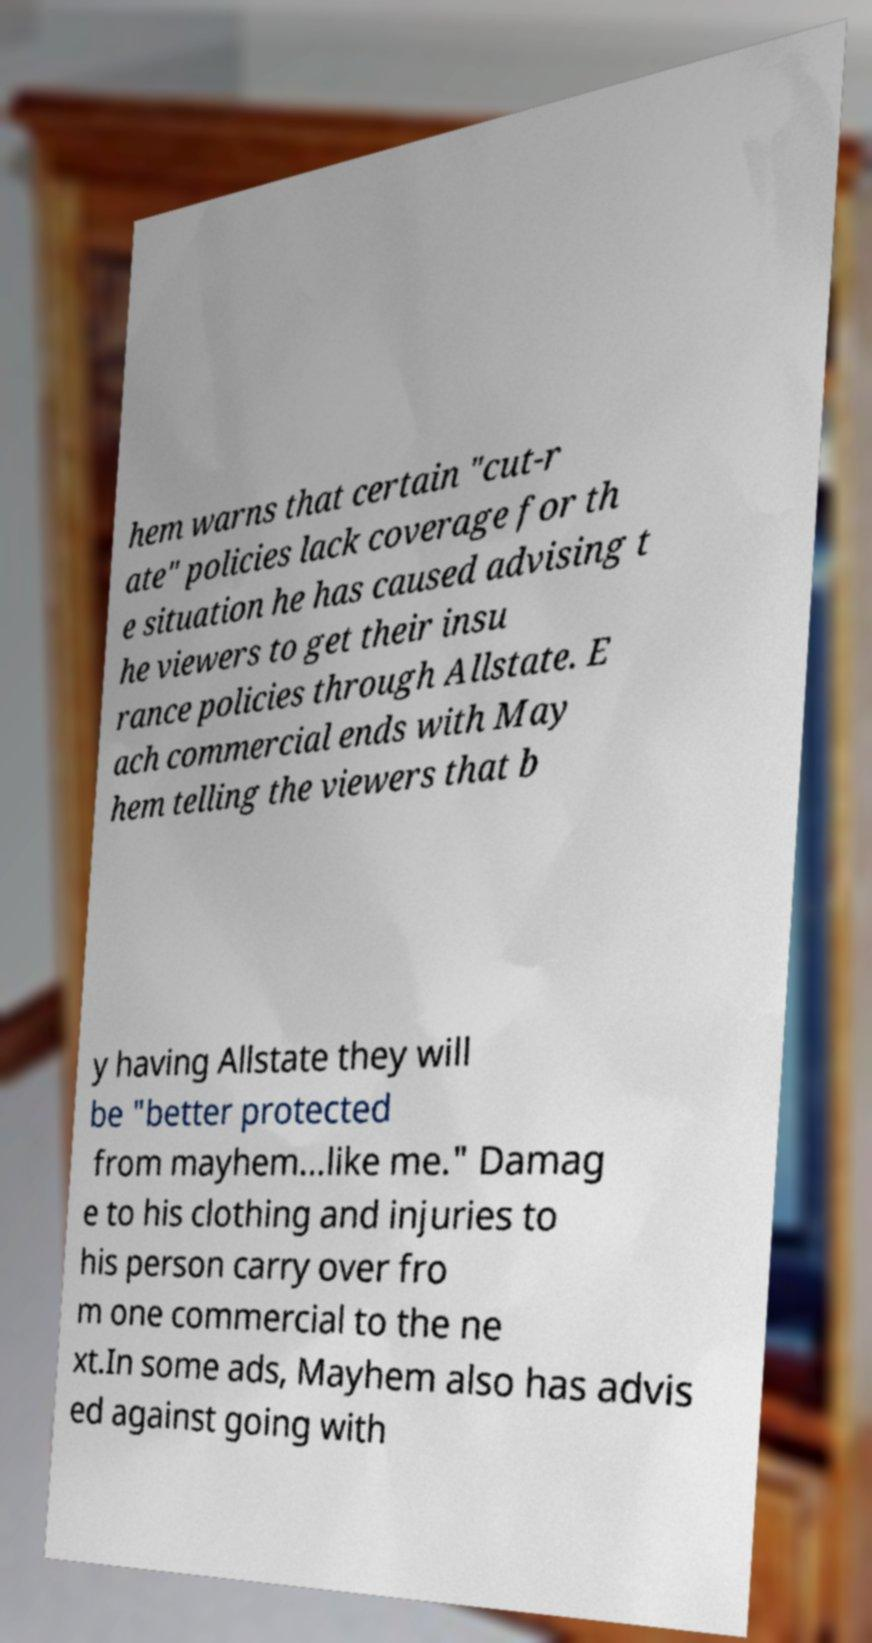I need the written content from this picture converted into text. Can you do that? hem warns that certain "cut-r ate" policies lack coverage for th e situation he has caused advising t he viewers to get their insu rance policies through Allstate. E ach commercial ends with May hem telling the viewers that b y having Allstate they will be "better protected from mayhem...like me." Damag e to his clothing and injuries to his person carry over fro m one commercial to the ne xt.In some ads, Mayhem also has advis ed against going with 